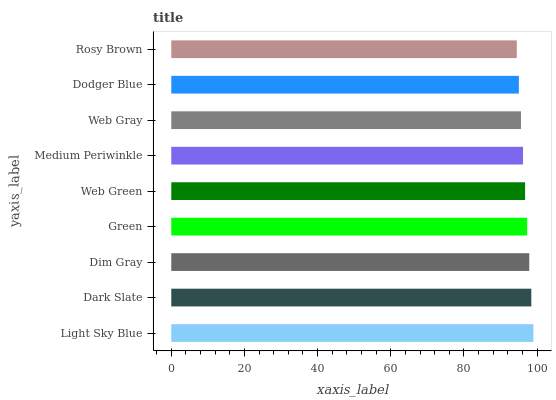Is Rosy Brown the minimum?
Answer yes or no. Yes. Is Light Sky Blue the maximum?
Answer yes or no. Yes. Is Dark Slate the minimum?
Answer yes or no. No. Is Dark Slate the maximum?
Answer yes or no. No. Is Light Sky Blue greater than Dark Slate?
Answer yes or no. Yes. Is Dark Slate less than Light Sky Blue?
Answer yes or no. Yes. Is Dark Slate greater than Light Sky Blue?
Answer yes or no. No. Is Light Sky Blue less than Dark Slate?
Answer yes or no. No. Is Web Green the high median?
Answer yes or no. Yes. Is Web Green the low median?
Answer yes or no. Yes. Is Dark Slate the high median?
Answer yes or no. No. Is Web Gray the low median?
Answer yes or no. No. 